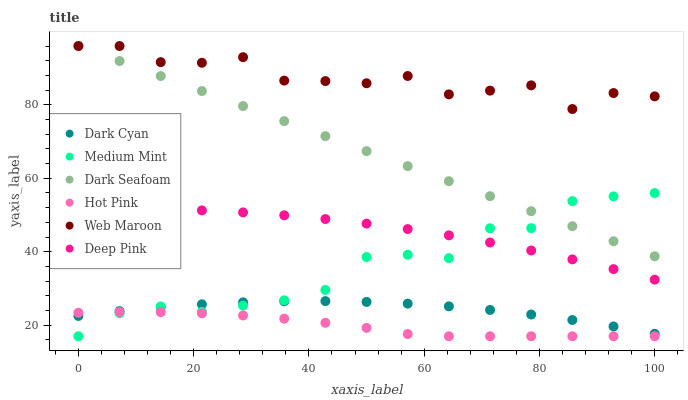Does Hot Pink have the minimum area under the curve?
Answer yes or no. Yes. Does Web Maroon have the maximum area under the curve?
Answer yes or no. Yes. Does Deep Pink have the minimum area under the curve?
Answer yes or no. No. Does Deep Pink have the maximum area under the curve?
Answer yes or no. No. Is Dark Seafoam the smoothest?
Answer yes or no. Yes. Is Web Maroon the roughest?
Answer yes or no. Yes. Is Deep Pink the smoothest?
Answer yes or no. No. Is Deep Pink the roughest?
Answer yes or no. No. Does Medium Mint have the lowest value?
Answer yes or no. Yes. Does Deep Pink have the lowest value?
Answer yes or no. No. Does Dark Seafoam have the highest value?
Answer yes or no. Yes. Does Deep Pink have the highest value?
Answer yes or no. No. Is Hot Pink less than Web Maroon?
Answer yes or no. Yes. Is Dark Seafoam greater than Hot Pink?
Answer yes or no. Yes. Does Medium Mint intersect Dark Seafoam?
Answer yes or no. Yes. Is Medium Mint less than Dark Seafoam?
Answer yes or no. No. Is Medium Mint greater than Dark Seafoam?
Answer yes or no. No. Does Hot Pink intersect Web Maroon?
Answer yes or no. No. 